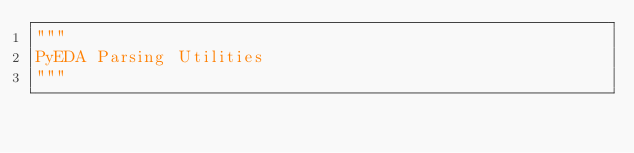<code> <loc_0><loc_0><loc_500><loc_500><_Python_>"""
PyEDA Parsing Utilities
"""

</code> 